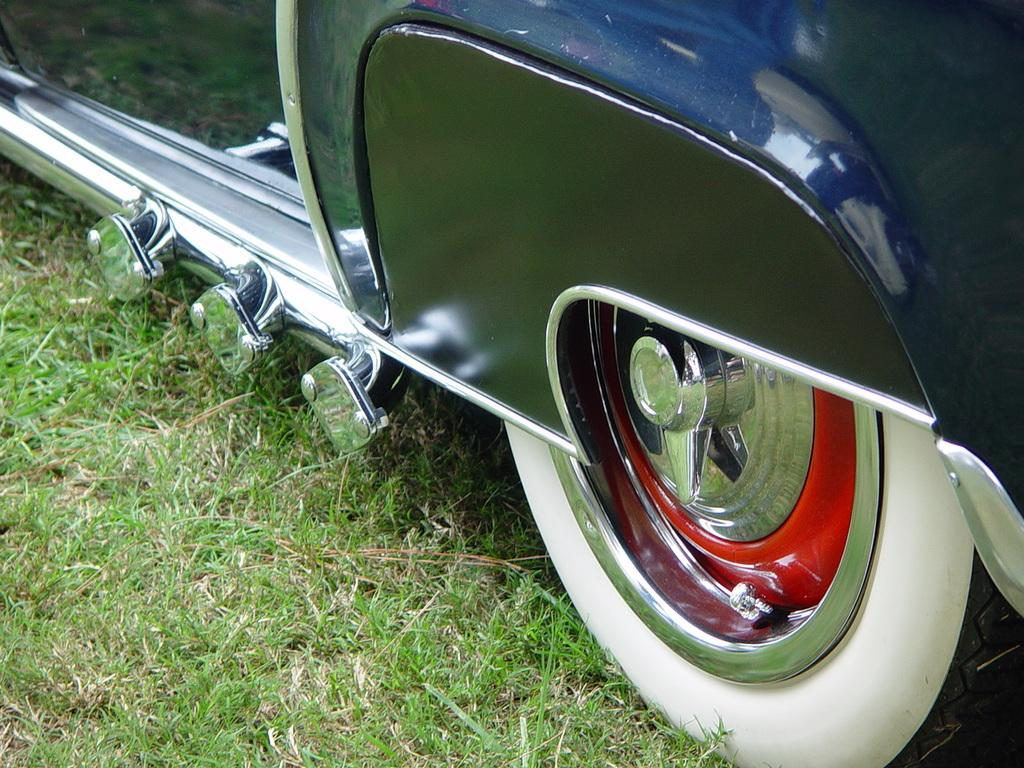What is the main subject of the image? There is a car in the image. Where is the car located in the image? The car is in the center of the image. What type of terrain is the car on? The car is on a grassland. What type of toothpaste is being used to clean the car in the image? There is no toothpaste or cleaning activity depicted in the image; it simply shows a car on a grassland. Can you see a tiger hiding behind the car in the image? There is no tiger present in the image; it only features a car on a grassland. 